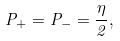<formula> <loc_0><loc_0><loc_500><loc_500>P _ { + } = P _ { - } = \frac { \eta } { 2 } ,</formula> 